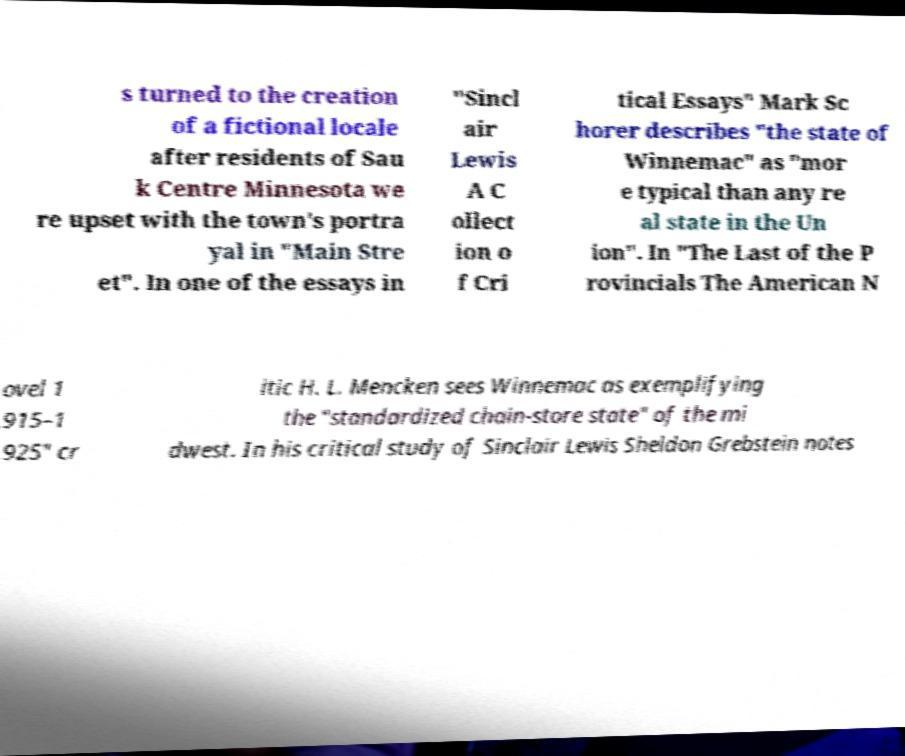Could you extract and type out the text from this image? s turned to the creation of a fictional locale after residents of Sau k Centre Minnesota we re upset with the town's portra yal in "Main Stre et". In one of the essays in "Sincl air Lewis A C ollect ion o f Cri tical Essays" Mark Sc horer describes "the state of Winnemac" as "mor e typical than any re al state in the Un ion". In "The Last of the P rovincials The American N ovel 1 915–1 925" cr itic H. L. Mencken sees Winnemac as exemplifying the "standardized chain-store state" of the mi dwest. In his critical study of Sinclair Lewis Sheldon Grebstein notes 